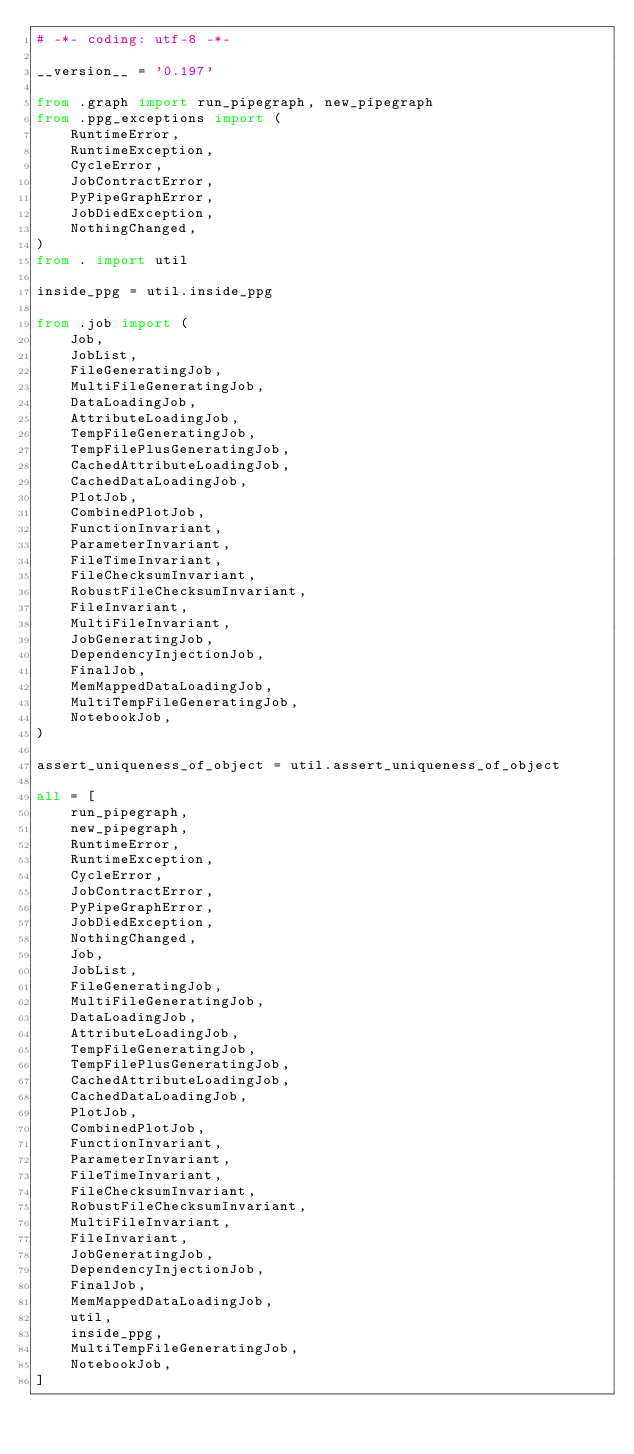<code> <loc_0><loc_0><loc_500><loc_500><_Python_># -*- coding: utf-8 -*-

__version__ = '0.197'

from .graph import run_pipegraph, new_pipegraph
from .ppg_exceptions import (
    RuntimeError,
    RuntimeException,
    CycleError,
    JobContractError,
    PyPipeGraphError,
    JobDiedException,
    NothingChanged,
)
from . import util

inside_ppg = util.inside_ppg

from .job import (
    Job,
    JobList,
    FileGeneratingJob,
    MultiFileGeneratingJob,
    DataLoadingJob,
    AttributeLoadingJob,
    TempFileGeneratingJob,
    TempFilePlusGeneratingJob,
    CachedAttributeLoadingJob,
    CachedDataLoadingJob,
    PlotJob,
    CombinedPlotJob,
    FunctionInvariant,
    ParameterInvariant,
    FileTimeInvariant,
    FileChecksumInvariant,
    RobustFileChecksumInvariant,
    FileInvariant,
    MultiFileInvariant,
    JobGeneratingJob,
    DependencyInjectionJob,
    FinalJob,
    MemMappedDataLoadingJob,
    MultiTempFileGeneratingJob,
    NotebookJob,
)

assert_uniqueness_of_object = util.assert_uniqueness_of_object

all = [
    run_pipegraph,
    new_pipegraph,
    RuntimeError,
    RuntimeException,
    CycleError,
    JobContractError,
    PyPipeGraphError,
    JobDiedException,
    NothingChanged,
    Job,
    JobList,
    FileGeneratingJob,
    MultiFileGeneratingJob,
    DataLoadingJob,
    AttributeLoadingJob,
    TempFileGeneratingJob,
    TempFilePlusGeneratingJob,
    CachedAttributeLoadingJob,
    CachedDataLoadingJob,
    PlotJob,
    CombinedPlotJob,
    FunctionInvariant,
    ParameterInvariant,
    FileTimeInvariant,
    FileChecksumInvariant,
    RobustFileChecksumInvariant,
    MultiFileInvariant,
    FileInvariant,
    JobGeneratingJob,
    DependencyInjectionJob,
    FinalJob,
    MemMappedDataLoadingJob,
    util,
    inside_ppg,
    MultiTempFileGeneratingJob,
    NotebookJob,
]
</code> 